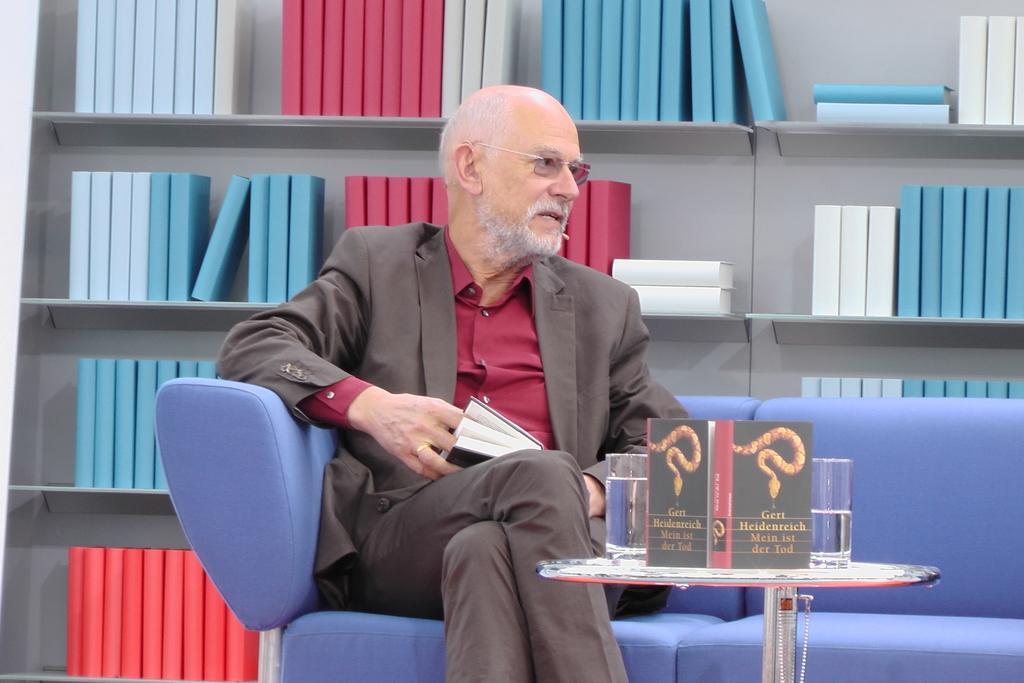Please provide a concise description of this image. In this picture we can see man sitting on sofa wore spectacle and talking on mic and in front of him there is table and on table we can see glass, card and in background we can see books in racks. 